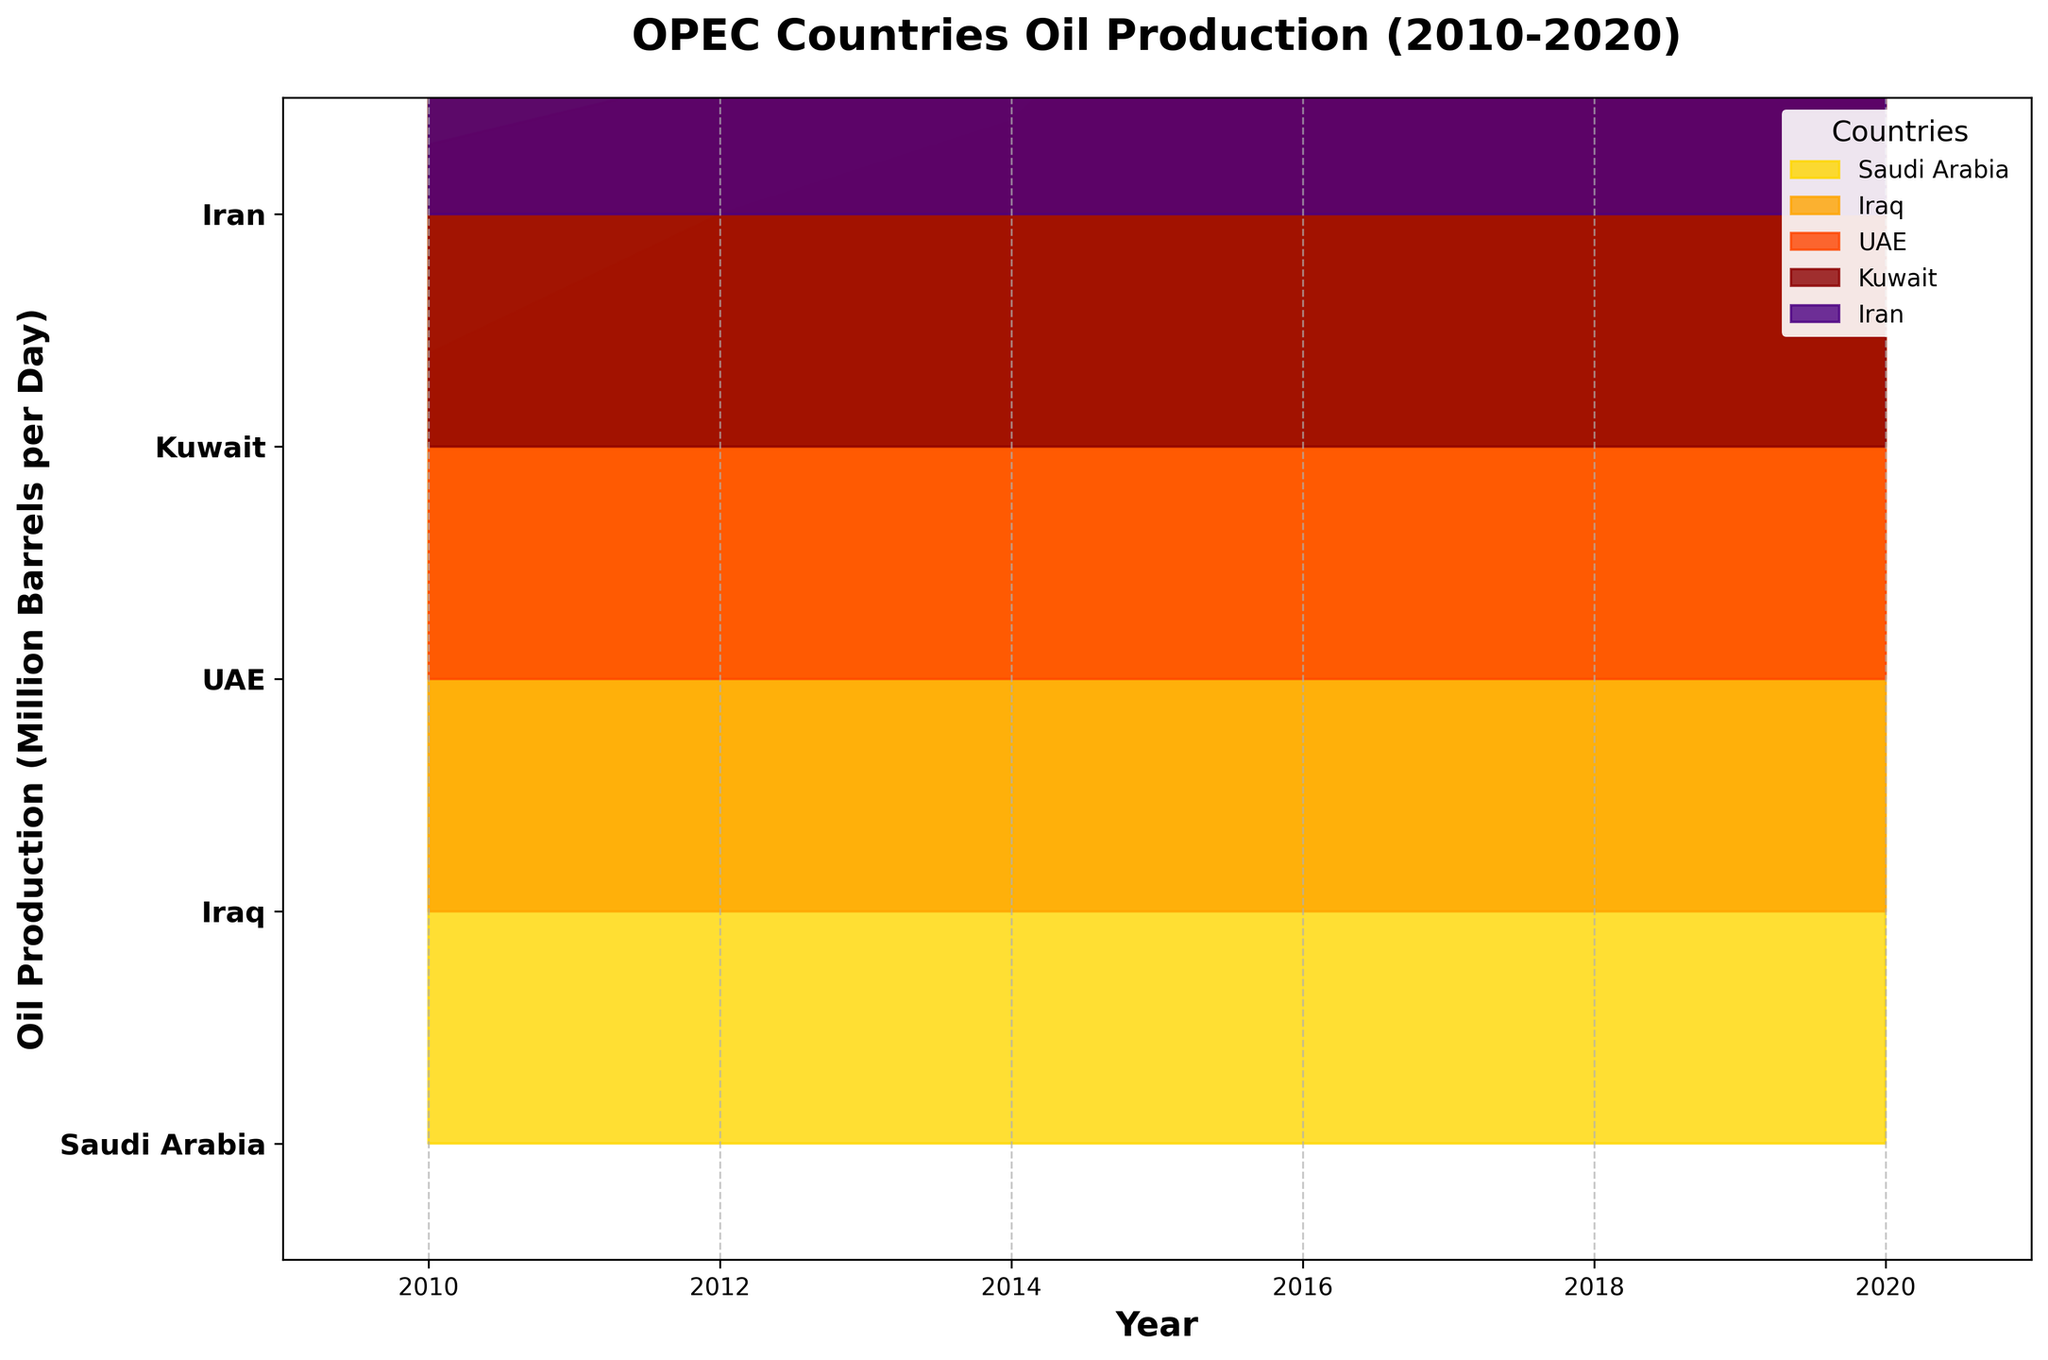What is the title of the figure? The title of the figure is prominently displayed at the top of the chart. It reads "OPEC Countries Oil Production (2010-2020)."
Answer: OPEC Countries Oil Production (2010-2020) Which country has the highest oil production in 2020? In the year 2020, the highest oil production level can be observed at the top of the plot for that year segment. The country with the highest production is Saudi Arabia.
Answer: Saudi Arabia What is the trend of Saudi Arabia's oil production from 2010 to 2020? By following the filled area corresponding to Saudi Arabia's production across the years 2010 to 2020, it can be observed that the production initially increases, peaks around 2016, and then decreases slightly towards 2020.
Answer: Increasing to peak in 2016, then decreasing Which country shows a steady increase in oil production from 2010 to 2016? By examining the upward trends in the plot from 2010 to 2016, it can be noted that Iraq's production increases steadily without much fluctuation.
Answer: Iraq Compare the oil production of Iran in 2014 and 2020. By comparing the filled areas for Iran in 2014 and 2020, it is visible that Iran's production decreases from 2.8 in 2014 to 2.0 in 2020.
Answer: Decreased In which year did the UAE have the highest oil production within the given timeframe? By tracing the filled area for the UAE across the years, it is seen that the highest production is in 2016 with a value of 3.1.
Answer: 2016 Which country experienced the most fluctuations in oil production between 2010 and 2020? This can be assessed by checking for significant changes in production levels over the years for each country. Saudi Arabia shows the most fluctuations with noticeable changes in production levels.
Answer: Saudi Arabia How does Kuwait's oil production in 2018 compare with that in 2020? By examining the filled area for Kuwait in 2018 and 2020, it shows that Kuwait's production was 2.7 in 2018 and it decreased to 2.4 in 2020.
Answer: Decreased Which two countries had nearly equal oil production in 2010? Looking at the filled areas in 2010, Kuwait and UAE had nearly equal production levels of 2.3 million barrels per day.
Answer: Kuwait and UAE 